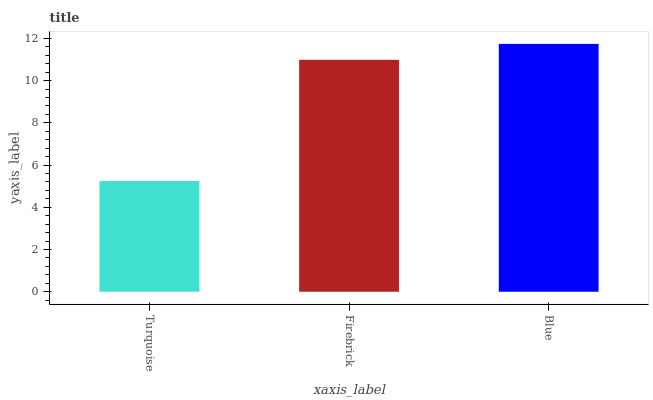Is Firebrick the minimum?
Answer yes or no. No. Is Firebrick the maximum?
Answer yes or no. No. Is Firebrick greater than Turquoise?
Answer yes or no. Yes. Is Turquoise less than Firebrick?
Answer yes or no. Yes. Is Turquoise greater than Firebrick?
Answer yes or no. No. Is Firebrick less than Turquoise?
Answer yes or no. No. Is Firebrick the high median?
Answer yes or no. Yes. Is Firebrick the low median?
Answer yes or no. Yes. Is Blue the high median?
Answer yes or no. No. Is Blue the low median?
Answer yes or no. No. 